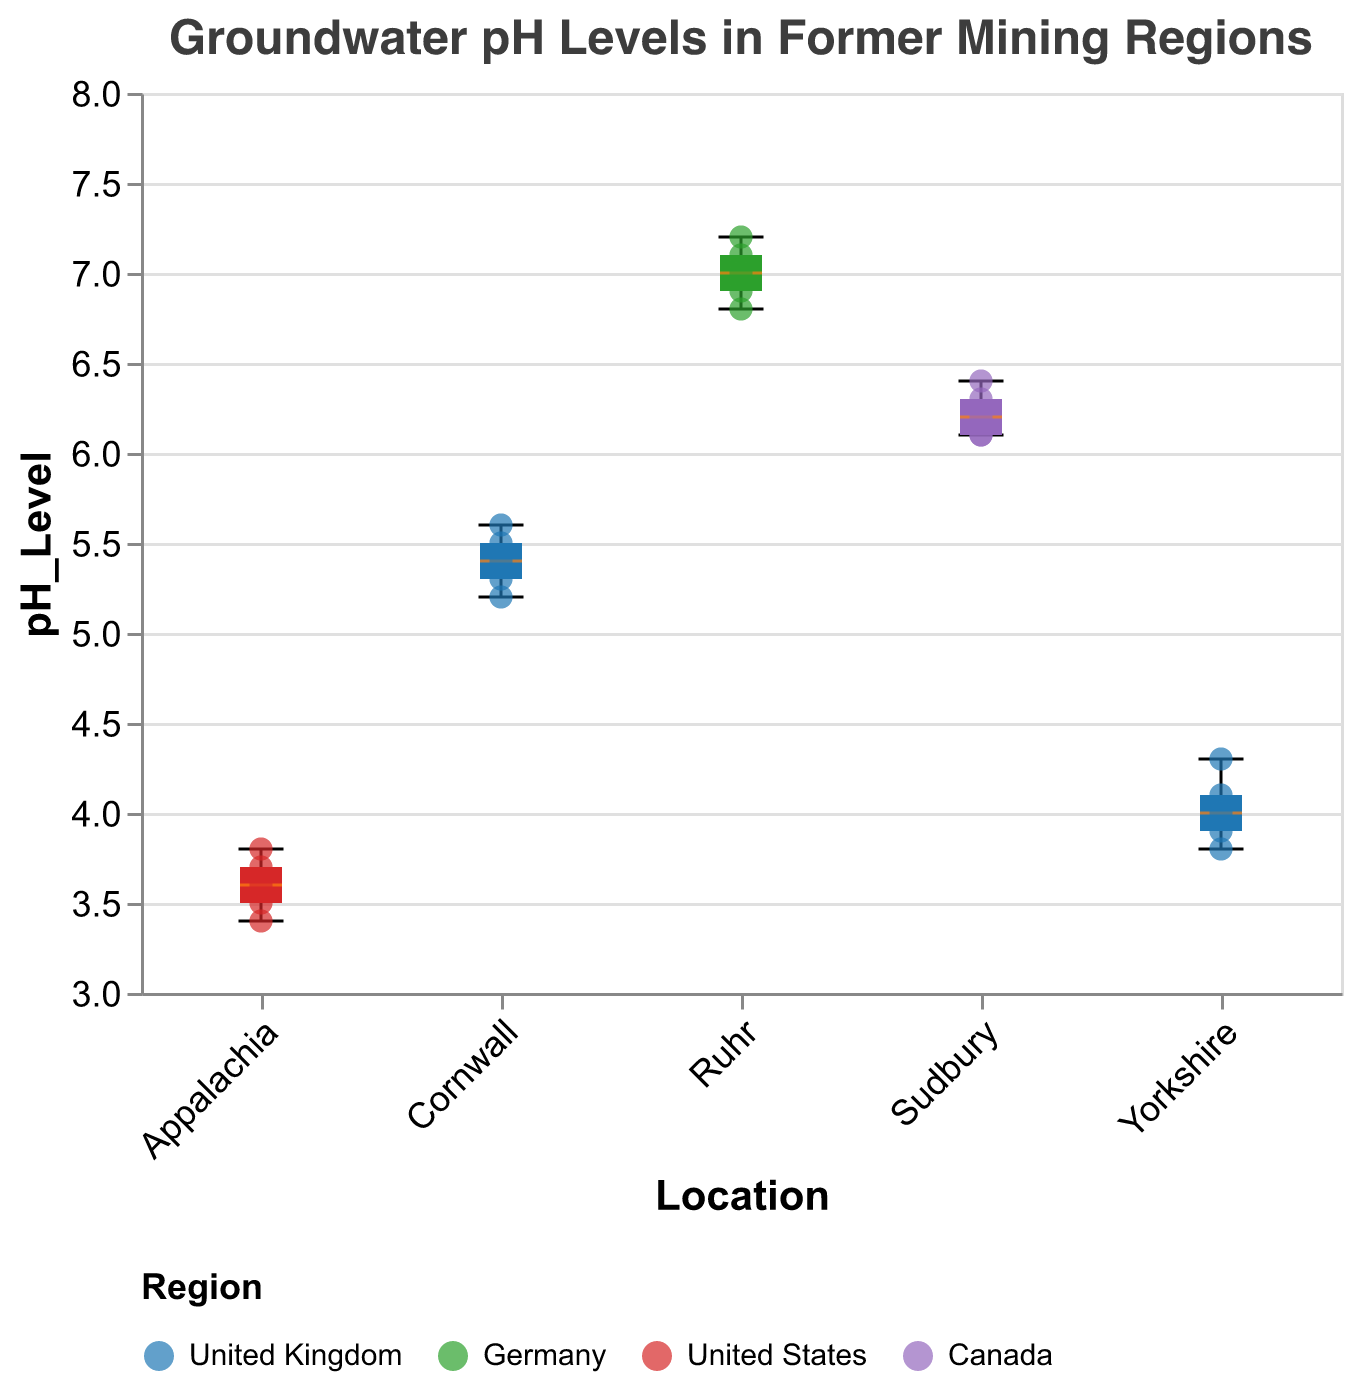What's the title of the figure? The title of the figure is displayed at the top and reads "Groundwater pH Levels in Former Mining Regions."
Answer: Groundwater pH Levels in Former Mining Regions Which region has the highest median pH level? The boxplot shows that the median (marked by the orange line) in the Ruhr (Germany) region is the highest among all regions.
Answer: Ruhr, Germany How many data points are reported for Yorkshire? Each scatter point represents a data point. By counting the scatter points for Yorkshire, we find there are 5 data points.
Answer: 5 Which region shows the greatest pH variation? The boxplot's whiskers represent the range (min-max). The greatest distance between the whiskers indicates the greatest variation. Yorkshire has the smallest variation.
Answer: Ruhr, Germany Which region has the lowest pH level and what is it? By examining the scatter points, we see that the lowest pH level occurs in Appalachia with a pH of 3.4.
Answer: Appalachia, 3.4 What is the median pH level in the Sudbury region? The median pH level is represented by the orange line in the Sudbury boxplot, which aligns with a pH level of 6.2.
Answer: 6.2 Compare the median pH levels of Cornwall and Yorkshire. Which is higher? The orange median line in Cornwall's boxplot is higher than that in Yorkshire's boxplot. Therefore, Cornwall has a higher median pH level than Yorkshire.
Answer: Cornwall Which region has the least number of pH levels below 4? By observing the scatter points, we see that Cornwall, Ruhr, and Sudbury have no pH levels below 4, meaning all their points are above 4.
Answer: Cornwall, Ruhr, Sudbury What is the interquartile range for the Ruhr region? The interquartile range (IQR) is the range between the first and third quartiles (edges of the box). For Ruhr, it spans from about 6.8 to 7.1, making the IQR 0.3.
Answer: 0.3 